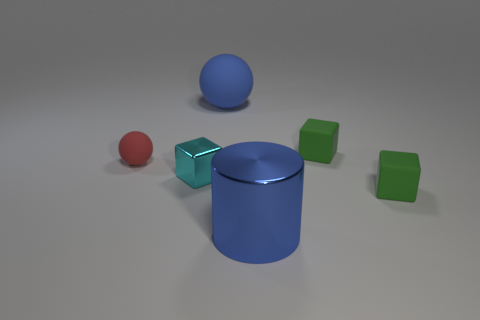Subtract all cyan cubes. How many cubes are left? 2 Subtract all cyan blocks. How many blocks are left? 2 Add 3 large things. How many objects exist? 9 Subtract 0 red cubes. How many objects are left? 6 Subtract all balls. How many objects are left? 4 Subtract all cyan cylinders. Subtract all red balls. How many cylinders are left? 1 Subtract all blue cylinders. How many green blocks are left? 2 Subtract all tiny brown matte objects. Subtract all small green rubber objects. How many objects are left? 4 Add 4 blue metallic cylinders. How many blue metallic cylinders are left? 5 Add 2 small green shiny spheres. How many small green shiny spheres exist? 2 